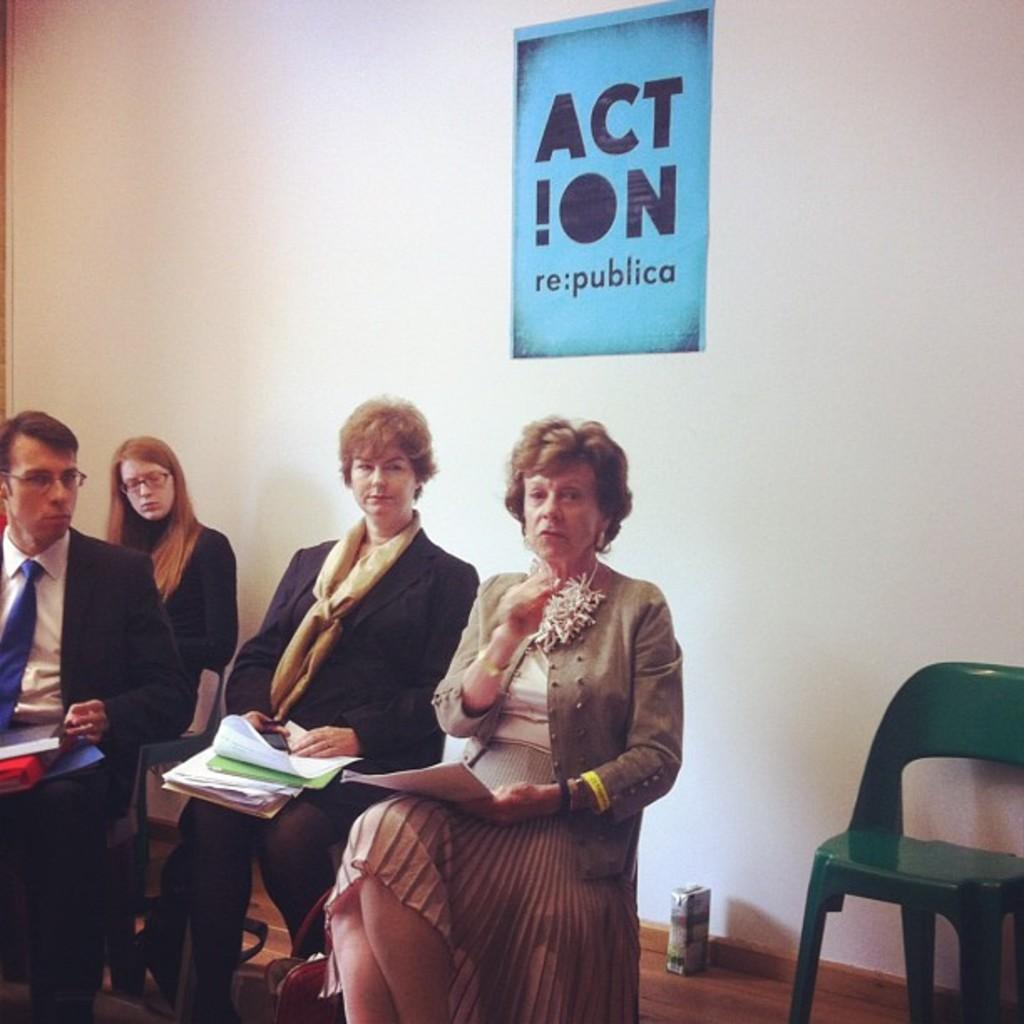Please provide a concise description of this image. In the picture we can see some people are sitting on the chairs and the backside we can find a wall and with the picture ACTION. 